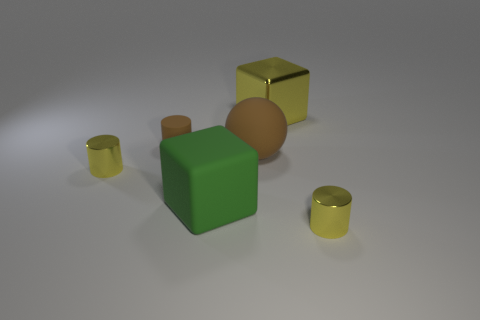What is the size of the matte thing behind the big brown matte object?
Make the answer very short. Small. Is the number of large yellow objects left of the large rubber block the same as the number of big brown matte objects that are behind the rubber sphere?
Offer a terse response. Yes. What is the color of the small shiny cylinder on the right side of the yellow cylinder to the left of the tiny object that is on the right side of the tiny matte object?
Offer a terse response. Yellow. How many yellow things are both right of the brown rubber cylinder and in front of the metal block?
Give a very brief answer. 1. There is a small thing to the right of the big yellow object; is it the same color as the tiny metal cylinder left of the big metallic thing?
Your response must be concise. Yes. There is a green matte thing that is the same shape as the big metal thing; what size is it?
Make the answer very short. Large. There is a large matte cube; are there any small yellow objects behind it?
Offer a terse response. Yes. Is the number of large blocks that are on the right side of the green matte thing the same as the number of big shiny things?
Offer a very short reply. Yes. There is a yellow metallic cylinder left of the tiny yellow metallic cylinder that is right of the green matte block; are there any small cylinders that are in front of it?
Provide a short and direct response. Yes. What is the big yellow block made of?
Your response must be concise. Metal. 